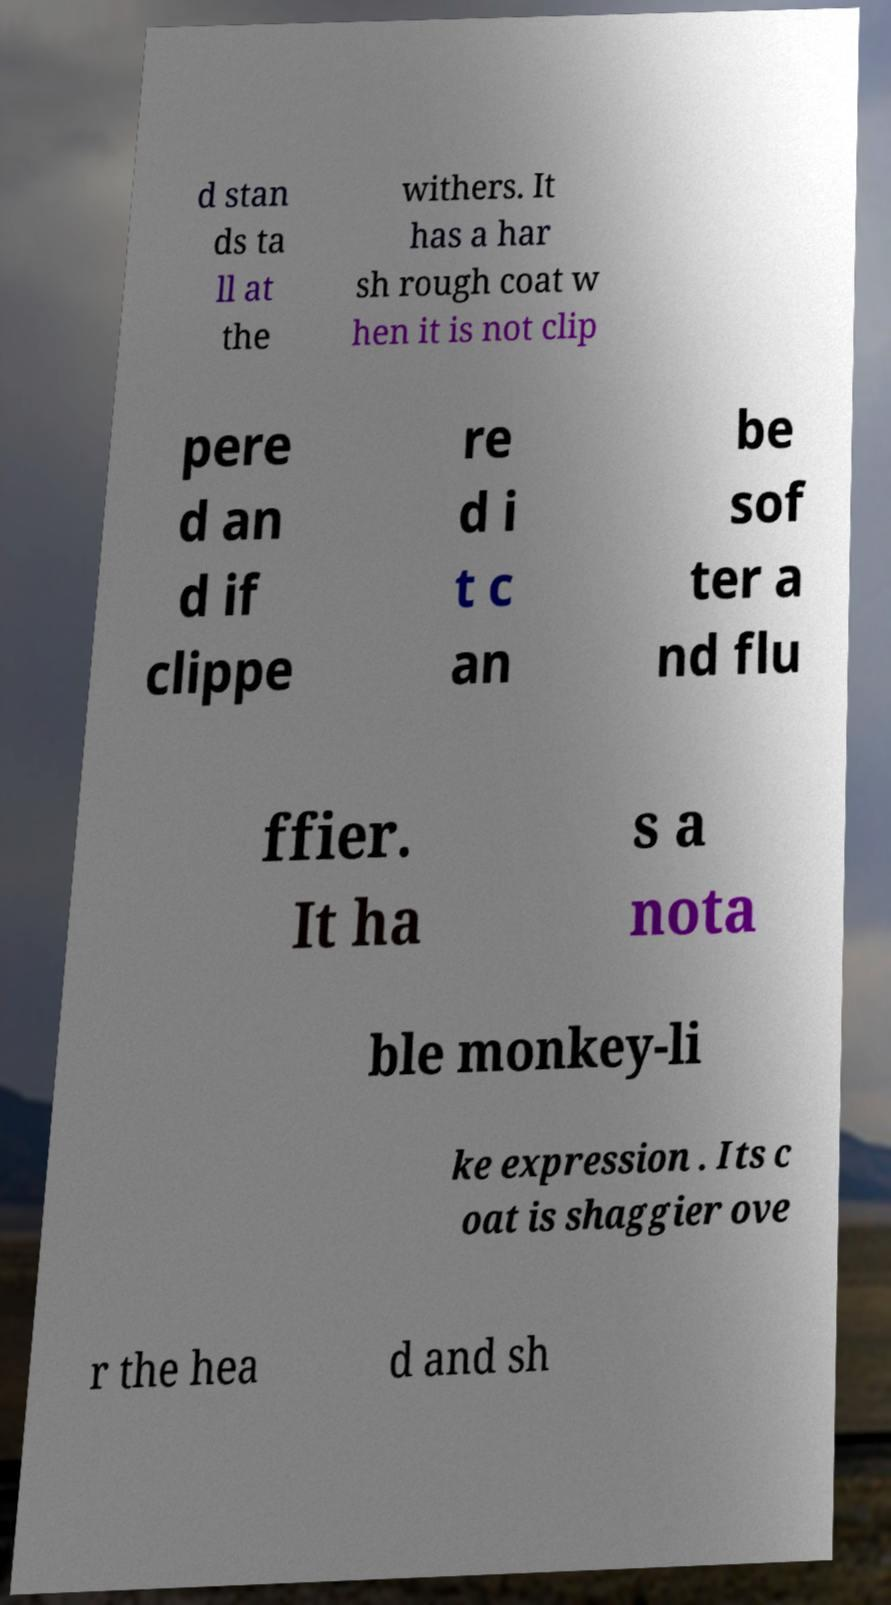What messages or text are displayed in this image? I need them in a readable, typed format. d stan ds ta ll at the withers. It has a har sh rough coat w hen it is not clip pere d an d if clippe re d i t c an be sof ter a nd flu ffier. It ha s a nota ble monkey-li ke expression . Its c oat is shaggier ove r the hea d and sh 